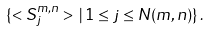Convert formula to latex. <formula><loc_0><loc_0><loc_500><loc_500>\{ < S ^ { m , n } _ { j } > \, | \, 1 \leq j \leq N ( m , n ) \} \, .</formula> 